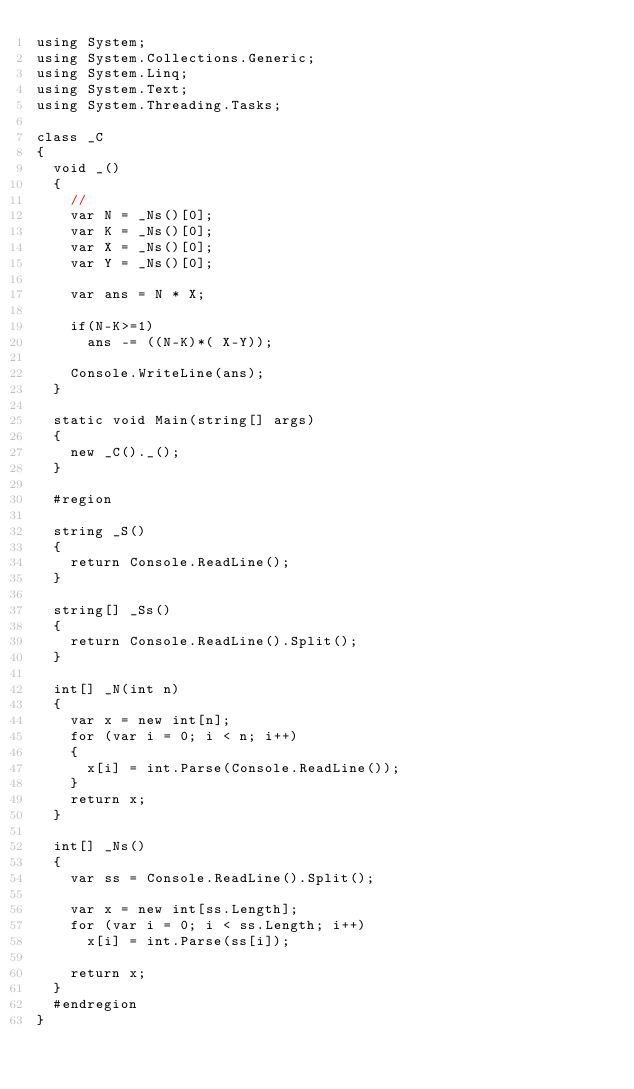Convert code to text. <code><loc_0><loc_0><loc_500><loc_500><_C#_>using System;
using System.Collections.Generic;
using System.Linq;
using System.Text;
using System.Threading.Tasks;

class _C
{
	void _()
	{
		//
		var N = _Ns()[0];
		var K = _Ns()[0];
		var X = _Ns()[0];
		var Y = _Ns()[0];

		var ans = N * X;

		if(N-K>=1)
			ans -= ((N-K)*( X-Y));

		Console.WriteLine(ans);
	}	

	static void Main(string[] args)
  {
    new _C()._();
  }

  #region

  string _S()
  {
    return Console.ReadLine();
  }

  string[] _Ss()
  {
    return Console.ReadLine().Split();
  }

  int[] _N(int n)
  {
    var x = new int[n];
    for (var i = 0; i < n; i++)
    {
      x[i] = int.Parse(Console.ReadLine());
    }
    return x;
  }

  int[] _Ns()
  {
    var ss = Console.ReadLine().Split();

    var x = new int[ss.Length];
    for (var i = 0; i < ss.Length; i++)
      x[i] = int.Parse(ss[i]);

    return x;
  }
  #endregion
}
</code> 